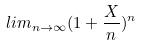<formula> <loc_0><loc_0><loc_500><loc_500>l i m _ { n \rightarrow \infty } ( 1 + \frac { X } { n } ) ^ { n }</formula> 